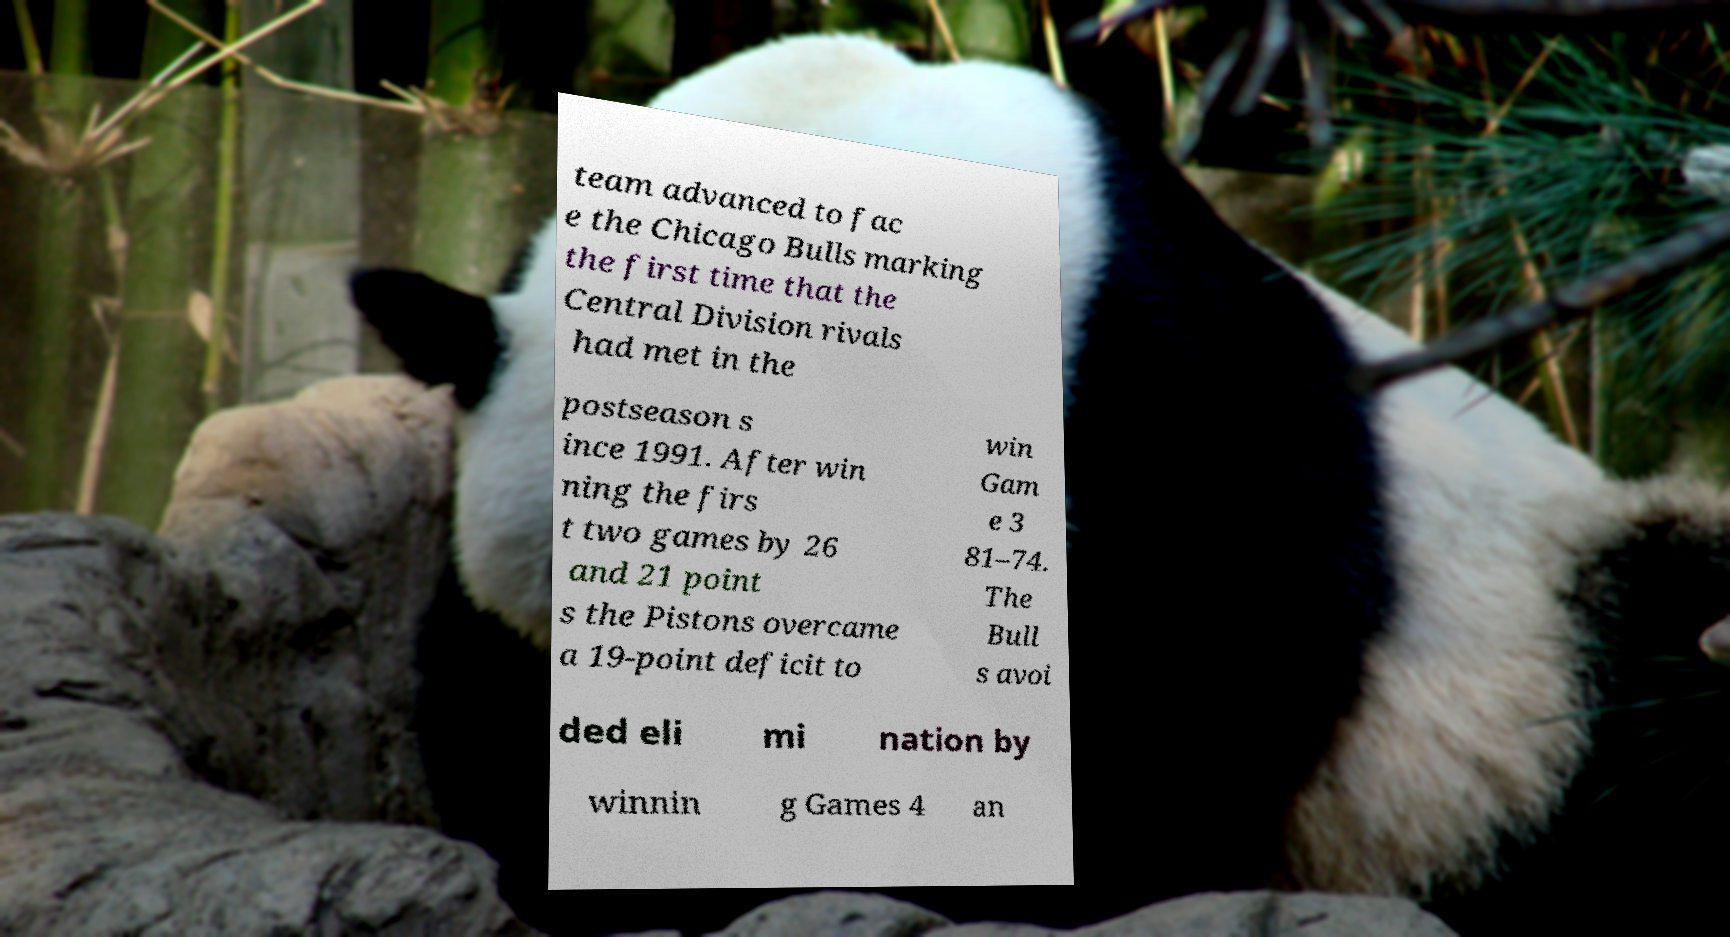Can you read and provide the text displayed in the image?This photo seems to have some interesting text. Can you extract and type it out for me? team advanced to fac e the Chicago Bulls marking the first time that the Central Division rivals had met in the postseason s ince 1991. After win ning the firs t two games by 26 and 21 point s the Pistons overcame a 19-point deficit to win Gam e 3 81–74. The Bull s avoi ded eli mi nation by winnin g Games 4 an 